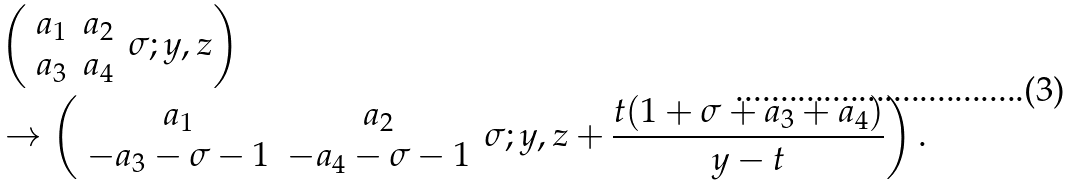Convert formula to latex. <formula><loc_0><loc_0><loc_500><loc_500>& \left ( \begin{array} { c c } a _ { 1 } & a _ { 2 } \\ a _ { 3 } & a _ { 4 } \end{array} \, \sigma ; y , z \right ) \\ & \to \left ( \begin{array} { c c } a _ { 1 } & a _ { 2 } \\ - a _ { 3 } - \sigma - 1 & - a _ { 4 } - \sigma - 1 \end{array} \, \sigma ; y , z + \frac { t ( 1 + \sigma + a _ { 3 } + a _ { 4 } ) } { y - t } \right ) .</formula> 